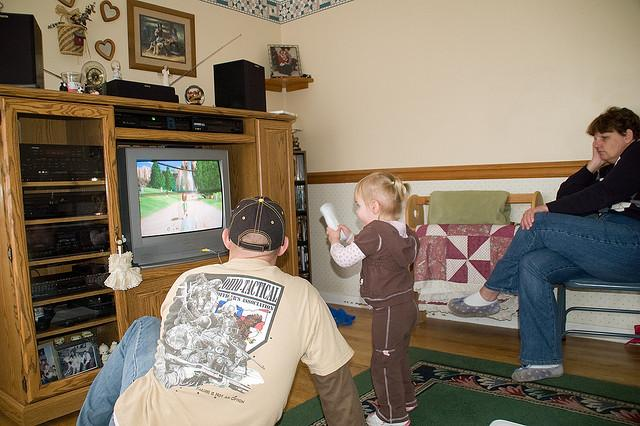What is the young girl doing with the white object? Please explain your reasoning. playing game. A girl is holding a video game controller in her hand. 